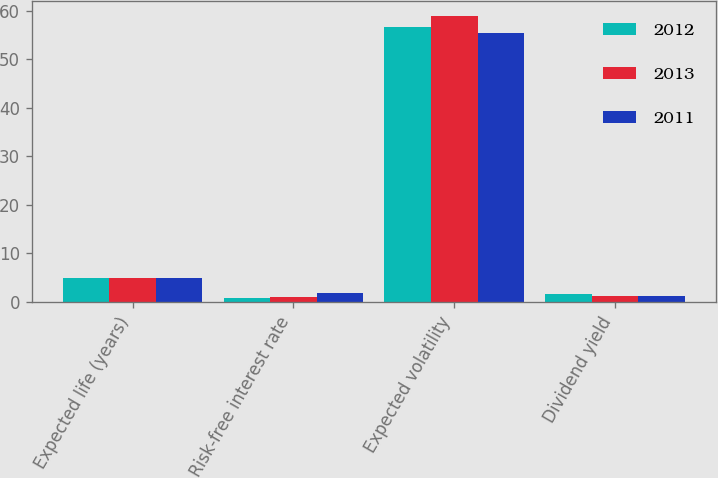Convert chart. <chart><loc_0><loc_0><loc_500><loc_500><stacked_bar_chart><ecel><fcel>Expected life (years)<fcel>Risk-free interest rate<fcel>Expected volatility<fcel>Dividend yield<nl><fcel>2012<fcel>5<fcel>0.79<fcel>56.59<fcel>1.55<nl><fcel>2013<fcel>5<fcel>1.05<fcel>58.98<fcel>1.3<nl><fcel>2011<fcel>5<fcel>1.87<fcel>55.39<fcel>1.3<nl></chart> 